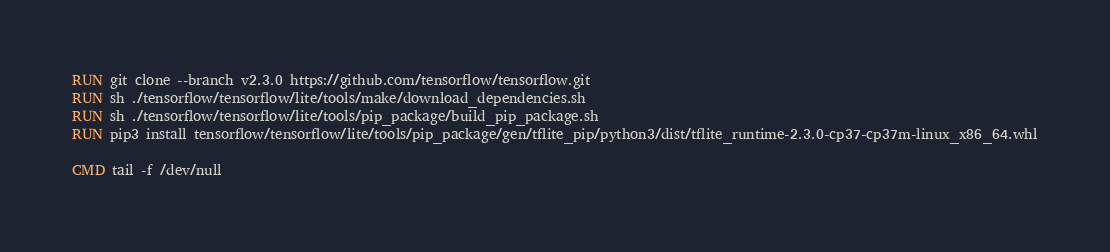<code> <loc_0><loc_0><loc_500><loc_500><_Dockerfile_>
RUN git clone --branch v2.3.0 https://github.com/tensorflow/tensorflow.git
RUN sh ./tensorflow/tensorflow/lite/tools/make/download_dependencies.sh
RUN sh ./tensorflow/tensorflow/lite/tools/pip_package/build_pip_package.sh
RUN pip3 install tensorflow/tensorflow/lite/tools/pip_package/gen/tflite_pip/python3/dist/tflite_runtime-2.3.0-cp37-cp37m-linux_x86_64.whl

CMD tail -f /dev/null</code> 